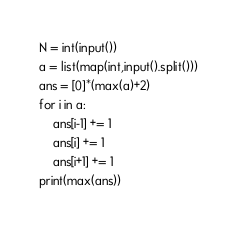<code> <loc_0><loc_0><loc_500><loc_500><_Python_>N = int(input())
a = list(map(int,input().split()))
ans = [0]*(max(a)+2)
for i in a:
    ans[i-1] += 1
    ans[i] += 1
    ans[i+1] += 1
print(max(ans))</code> 